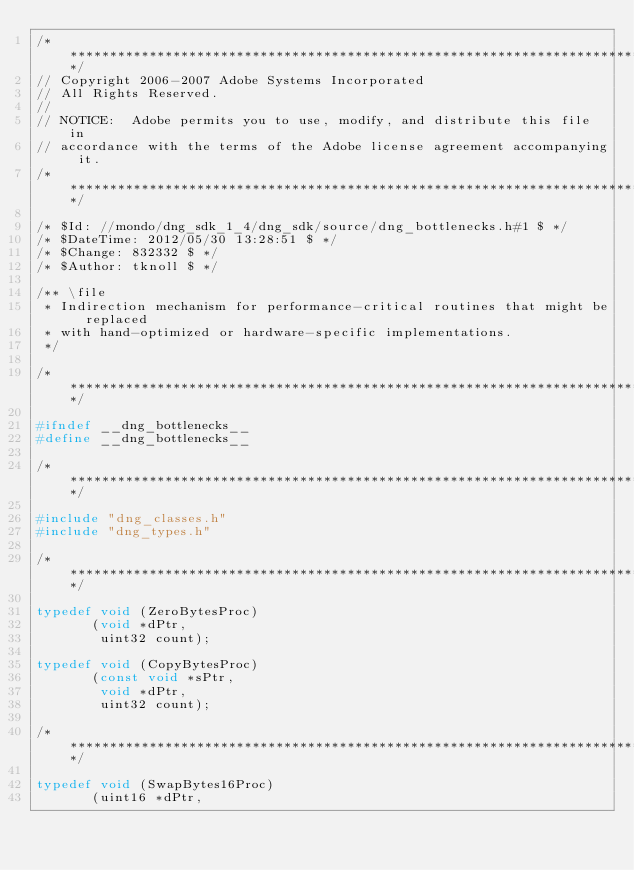<code> <loc_0><loc_0><loc_500><loc_500><_C_>/*****************************************************************************/
// Copyright 2006-2007 Adobe Systems Incorporated
// All Rights Reserved.
//
// NOTICE:  Adobe permits you to use, modify, and distribute this file in
// accordance with the terms of the Adobe license agreement accompanying it.
/*****************************************************************************/

/* $Id: //mondo/dng_sdk_1_4/dng_sdk/source/dng_bottlenecks.h#1 $ */ 
/* $DateTime: 2012/05/30 13:28:51 $ */
/* $Change: 832332 $ */
/* $Author: tknoll $ */

/** \file
 * Indirection mechanism for performance-critical routines that might be replaced
 * with hand-optimized or hardware-specific implementations.
 */

/*****************************************************************************/

#ifndef __dng_bottlenecks__
#define __dng_bottlenecks__

/*****************************************************************************/

#include "dng_classes.h"
#include "dng_types.h"

/*****************************************************************************/

typedef void (ZeroBytesProc)
			 (void *dPtr,
			  uint32 count);

typedef void (CopyBytesProc)
			 (const void *sPtr,
			  void *dPtr,
			  uint32 count);

/*****************************************************************************/

typedef void (SwapBytes16Proc)
			 (uint16 *dPtr,</code> 